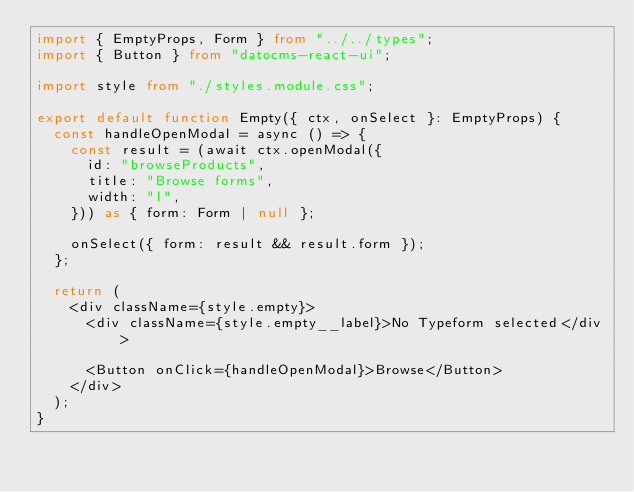Convert code to text. <code><loc_0><loc_0><loc_500><loc_500><_TypeScript_>import { EmptyProps, Form } from "../../types";
import { Button } from "datocms-react-ui";

import style from "./styles.module.css";

export default function Empty({ ctx, onSelect }: EmptyProps) {
  const handleOpenModal = async () => {
    const result = (await ctx.openModal({
      id: "browseProducts",
      title: "Browse forms",
      width: "l",
    })) as { form: Form | null };

    onSelect({ form: result && result.form });
  };

  return (
    <div className={style.empty}>
      <div className={style.empty__label}>No Typeform selected</div>

      <Button onClick={handleOpenModal}>Browse</Button>
    </div>
  );
}
</code> 